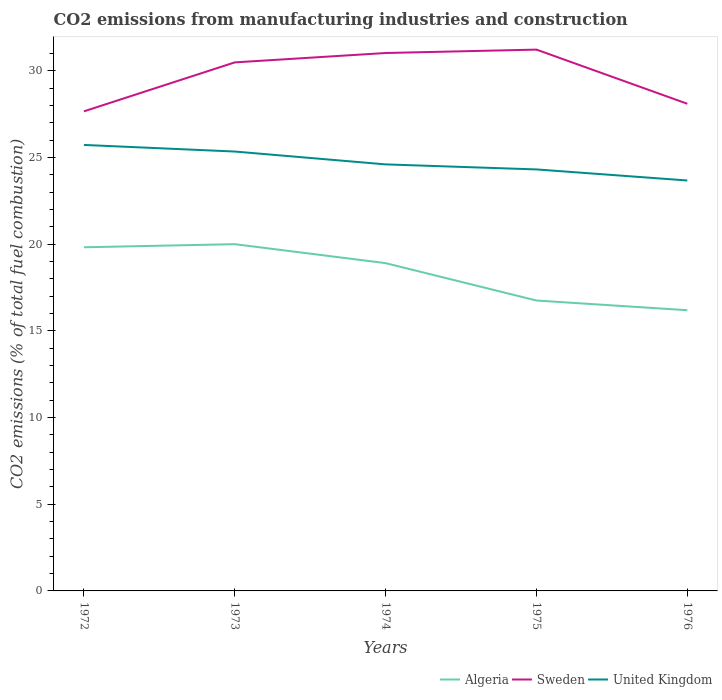Is the number of lines equal to the number of legend labels?
Offer a very short reply. Yes. Across all years, what is the maximum amount of CO2 emitted in Algeria?
Your answer should be compact. 16.19. In which year was the amount of CO2 emitted in Sweden maximum?
Your answer should be compact. 1972. What is the total amount of CO2 emitted in United Kingdom in the graph?
Ensure brevity in your answer.  0.64. What is the difference between the highest and the second highest amount of CO2 emitted in Algeria?
Your response must be concise. 3.81. Is the amount of CO2 emitted in Algeria strictly greater than the amount of CO2 emitted in United Kingdom over the years?
Provide a short and direct response. Yes. Are the values on the major ticks of Y-axis written in scientific E-notation?
Your response must be concise. No. Does the graph contain any zero values?
Offer a very short reply. No. Does the graph contain grids?
Your answer should be very brief. No. How many legend labels are there?
Provide a succinct answer. 3. What is the title of the graph?
Offer a terse response. CO2 emissions from manufacturing industries and construction. What is the label or title of the X-axis?
Offer a very short reply. Years. What is the label or title of the Y-axis?
Keep it short and to the point. CO2 emissions (% of total fuel combustion). What is the CO2 emissions (% of total fuel combustion) of Algeria in 1972?
Keep it short and to the point. 19.82. What is the CO2 emissions (% of total fuel combustion) in Sweden in 1972?
Your answer should be compact. 27.66. What is the CO2 emissions (% of total fuel combustion) of United Kingdom in 1972?
Give a very brief answer. 25.72. What is the CO2 emissions (% of total fuel combustion) of Sweden in 1973?
Make the answer very short. 30.48. What is the CO2 emissions (% of total fuel combustion) of United Kingdom in 1973?
Keep it short and to the point. 25.34. What is the CO2 emissions (% of total fuel combustion) in Algeria in 1974?
Provide a short and direct response. 18.91. What is the CO2 emissions (% of total fuel combustion) in Sweden in 1974?
Your response must be concise. 31.03. What is the CO2 emissions (% of total fuel combustion) of United Kingdom in 1974?
Offer a terse response. 24.6. What is the CO2 emissions (% of total fuel combustion) in Algeria in 1975?
Provide a short and direct response. 16.75. What is the CO2 emissions (% of total fuel combustion) of Sweden in 1975?
Your response must be concise. 31.22. What is the CO2 emissions (% of total fuel combustion) of United Kingdom in 1975?
Make the answer very short. 24.31. What is the CO2 emissions (% of total fuel combustion) of Algeria in 1976?
Your answer should be compact. 16.19. What is the CO2 emissions (% of total fuel combustion) of Sweden in 1976?
Keep it short and to the point. 28.1. What is the CO2 emissions (% of total fuel combustion) in United Kingdom in 1976?
Provide a succinct answer. 23.67. Across all years, what is the maximum CO2 emissions (% of total fuel combustion) of Sweden?
Your response must be concise. 31.22. Across all years, what is the maximum CO2 emissions (% of total fuel combustion) of United Kingdom?
Give a very brief answer. 25.72. Across all years, what is the minimum CO2 emissions (% of total fuel combustion) of Algeria?
Your answer should be very brief. 16.19. Across all years, what is the minimum CO2 emissions (% of total fuel combustion) of Sweden?
Your response must be concise. 27.66. Across all years, what is the minimum CO2 emissions (% of total fuel combustion) of United Kingdom?
Your response must be concise. 23.67. What is the total CO2 emissions (% of total fuel combustion) of Algeria in the graph?
Provide a succinct answer. 91.67. What is the total CO2 emissions (% of total fuel combustion) of Sweden in the graph?
Give a very brief answer. 148.49. What is the total CO2 emissions (% of total fuel combustion) of United Kingdom in the graph?
Provide a succinct answer. 123.65. What is the difference between the CO2 emissions (% of total fuel combustion) of Algeria in 1972 and that in 1973?
Offer a very short reply. -0.18. What is the difference between the CO2 emissions (% of total fuel combustion) in Sweden in 1972 and that in 1973?
Offer a very short reply. -2.82. What is the difference between the CO2 emissions (% of total fuel combustion) of United Kingdom in 1972 and that in 1973?
Provide a succinct answer. 0.38. What is the difference between the CO2 emissions (% of total fuel combustion) in Algeria in 1972 and that in 1974?
Your answer should be very brief. 0.91. What is the difference between the CO2 emissions (% of total fuel combustion) in Sweden in 1972 and that in 1974?
Keep it short and to the point. -3.37. What is the difference between the CO2 emissions (% of total fuel combustion) in United Kingdom in 1972 and that in 1974?
Ensure brevity in your answer.  1.12. What is the difference between the CO2 emissions (% of total fuel combustion) in Algeria in 1972 and that in 1975?
Your answer should be very brief. 3.07. What is the difference between the CO2 emissions (% of total fuel combustion) of Sweden in 1972 and that in 1975?
Offer a very short reply. -3.56. What is the difference between the CO2 emissions (% of total fuel combustion) of United Kingdom in 1972 and that in 1975?
Offer a terse response. 1.41. What is the difference between the CO2 emissions (% of total fuel combustion) of Algeria in 1972 and that in 1976?
Provide a short and direct response. 3.63. What is the difference between the CO2 emissions (% of total fuel combustion) in Sweden in 1972 and that in 1976?
Provide a succinct answer. -0.44. What is the difference between the CO2 emissions (% of total fuel combustion) in United Kingdom in 1972 and that in 1976?
Offer a very short reply. 2.05. What is the difference between the CO2 emissions (% of total fuel combustion) in Algeria in 1973 and that in 1974?
Your response must be concise. 1.09. What is the difference between the CO2 emissions (% of total fuel combustion) in Sweden in 1973 and that in 1974?
Your answer should be very brief. -0.54. What is the difference between the CO2 emissions (% of total fuel combustion) in United Kingdom in 1973 and that in 1974?
Provide a short and direct response. 0.74. What is the difference between the CO2 emissions (% of total fuel combustion) of Algeria in 1973 and that in 1975?
Your answer should be very brief. 3.25. What is the difference between the CO2 emissions (% of total fuel combustion) of Sweden in 1973 and that in 1975?
Provide a short and direct response. -0.74. What is the difference between the CO2 emissions (% of total fuel combustion) in United Kingdom in 1973 and that in 1975?
Offer a very short reply. 1.03. What is the difference between the CO2 emissions (% of total fuel combustion) in Algeria in 1973 and that in 1976?
Offer a very short reply. 3.81. What is the difference between the CO2 emissions (% of total fuel combustion) of Sweden in 1973 and that in 1976?
Your answer should be very brief. 2.39. What is the difference between the CO2 emissions (% of total fuel combustion) in United Kingdom in 1973 and that in 1976?
Offer a very short reply. 1.67. What is the difference between the CO2 emissions (% of total fuel combustion) of Algeria in 1974 and that in 1975?
Offer a terse response. 2.16. What is the difference between the CO2 emissions (% of total fuel combustion) in Sweden in 1974 and that in 1975?
Provide a short and direct response. -0.2. What is the difference between the CO2 emissions (% of total fuel combustion) in United Kingdom in 1974 and that in 1975?
Offer a very short reply. 0.29. What is the difference between the CO2 emissions (% of total fuel combustion) of Algeria in 1974 and that in 1976?
Offer a terse response. 2.72. What is the difference between the CO2 emissions (% of total fuel combustion) of Sweden in 1974 and that in 1976?
Your answer should be very brief. 2.93. What is the difference between the CO2 emissions (% of total fuel combustion) of United Kingdom in 1974 and that in 1976?
Offer a terse response. 0.93. What is the difference between the CO2 emissions (% of total fuel combustion) in Algeria in 1975 and that in 1976?
Make the answer very short. 0.56. What is the difference between the CO2 emissions (% of total fuel combustion) of Sweden in 1975 and that in 1976?
Provide a succinct answer. 3.12. What is the difference between the CO2 emissions (% of total fuel combustion) of United Kingdom in 1975 and that in 1976?
Your answer should be compact. 0.64. What is the difference between the CO2 emissions (% of total fuel combustion) of Algeria in 1972 and the CO2 emissions (% of total fuel combustion) of Sweden in 1973?
Your answer should be very brief. -10.66. What is the difference between the CO2 emissions (% of total fuel combustion) in Algeria in 1972 and the CO2 emissions (% of total fuel combustion) in United Kingdom in 1973?
Your answer should be compact. -5.52. What is the difference between the CO2 emissions (% of total fuel combustion) of Sweden in 1972 and the CO2 emissions (% of total fuel combustion) of United Kingdom in 1973?
Ensure brevity in your answer.  2.32. What is the difference between the CO2 emissions (% of total fuel combustion) of Algeria in 1972 and the CO2 emissions (% of total fuel combustion) of Sweden in 1974?
Your answer should be compact. -11.21. What is the difference between the CO2 emissions (% of total fuel combustion) of Algeria in 1972 and the CO2 emissions (% of total fuel combustion) of United Kingdom in 1974?
Provide a succinct answer. -4.78. What is the difference between the CO2 emissions (% of total fuel combustion) of Sweden in 1972 and the CO2 emissions (% of total fuel combustion) of United Kingdom in 1974?
Your response must be concise. 3.06. What is the difference between the CO2 emissions (% of total fuel combustion) in Algeria in 1972 and the CO2 emissions (% of total fuel combustion) in Sweden in 1975?
Offer a terse response. -11.4. What is the difference between the CO2 emissions (% of total fuel combustion) of Algeria in 1972 and the CO2 emissions (% of total fuel combustion) of United Kingdom in 1975?
Provide a short and direct response. -4.49. What is the difference between the CO2 emissions (% of total fuel combustion) of Sweden in 1972 and the CO2 emissions (% of total fuel combustion) of United Kingdom in 1975?
Offer a very short reply. 3.35. What is the difference between the CO2 emissions (% of total fuel combustion) of Algeria in 1972 and the CO2 emissions (% of total fuel combustion) of Sweden in 1976?
Give a very brief answer. -8.28. What is the difference between the CO2 emissions (% of total fuel combustion) in Algeria in 1972 and the CO2 emissions (% of total fuel combustion) in United Kingdom in 1976?
Your answer should be compact. -3.85. What is the difference between the CO2 emissions (% of total fuel combustion) of Sweden in 1972 and the CO2 emissions (% of total fuel combustion) of United Kingdom in 1976?
Provide a succinct answer. 3.99. What is the difference between the CO2 emissions (% of total fuel combustion) of Algeria in 1973 and the CO2 emissions (% of total fuel combustion) of Sweden in 1974?
Offer a very short reply. -11.03. What is the difference between the CO2 emissions (% of total fuel combustion) in Algeria in 1973 and the CO2 emissions (% of total fuel combustion) in United Kingdom in 1974?
Your answer should be compact. -4.6. What is the difference between the CO2 emissions (% of total fuel combustion) of Sweden in 1973 and the CO2 emissions (% of total fuel combustion) of United Kingdom in 1974?
Offer a terse response. 5.88. What is the difference between the CO2 emissions (% of total fuel combustion) in Algeria in 1973 and the CO2 emissions (% of total fuel combustion) in Sweden in 1975?
Provide a short and direct response. -11.22. What is the difference between the CO2 emissions (% of total fuel combustion) in Algeria in 1973 and the CO2 emissions (% of total fuel combustion) in United Kingdom in 1975?
Offer a very short reply. -4.31. What is the difference between the CO2 emissions (% of total fuel combustion) in Sweden in 1973 and the CO2 emissions (% of total fuel combustion) in United Kingdom in 1975?
Ensure brevity in your answer.  6.17. What is the difference between the CO2 emissions (% of total fuel combustion) in Algeria in 1973 and the CO2 emissions (% of total fuel combustion) in Sweden in 1976?
Offer a terse response. -8.1. What is the difference between the CO2 emissions (% of total fuel combustion) in Algeria in 1973 and the CO2 emissions (% of total fuel combustion) in United Kingdom in 1976?
Give a very brief answer. -3.67. What is the difference between the CO2 emissions (% of total fuel combustion) in Sweden in 1973 and the CO2 emissions (% of total fuel combustion) in United Kingdom in 1976?
Provide a succinct answer. 6.81. What is the difference between the CO2 emissions (% of total fuel combustion) of Algeria in 1974 and the CO2 emissions (% of total fuel combustion) of Sweden in 1975?
Your answer should be compact. -12.32. What is the difference between the CO2 emissions (% of total fuel combustion) in Algeria in 1974 and the CO2 emissions (% of total fuel combustion) in United Kingdom in 1975?
Make the answer very short. -5.41. What is the difference between the CO2 emissions (% of total fuel combustion) in Sweden in 1974 and the CO2 emissions (% of total fuel combustion) in United Kingdom in 1975?
Ensure brevity in your answer.  6.71. What is the difference between the CO2 emissions (% of total fuel combustion) of Algeria in 1974 and the CO2 emissions (% of total fuel combustion) of Sweden in 1976?
Make the answer very short. -9.19. What is the difference between the CO2 emissions (% of total fuel combustion) in Algeria in 1974 and the CO2 emissions (% of total fuel combustion) in United Kingdom in 1976?
Provide a succinct answer. -4.77. What is the difference between the CO2 emissions (% of total fuel combustion) of Sweden in 1974 and the CO2 emissions (% of total fuel combustion) of United Kingdom in 1976?
Your response must be concise. 7.35. What is the difference between the CO2 emissions (% of total fuel combustion) in Algeria in 1975 and the CO2 emissions (% of total fuel combustion) in Sweden in 1976?
Offer a very short reply. -11.35. What is the difference between the CO2 emissions (% of total fuel combustion) of Algeria in 1975 and the CO2 emissions (% of total fuel combustion) of United Kingdom in 1976?
Your answer should be very brief. -6.92. What is the difference between the CO2 emissions (% of total fuel combustion) in Sweden in 1975 and the CO2 emissions (% of total fuel combustion) in United Kingdom in 1976?
Provide a short and direct response. 7.55. What is the average CO2 emissions (% of total fuel combustion) in Algeria per year?
Make the answer very short. 18.33. What is the average CO2 emissions (% of total fuel combustion) of Sweden per year?
Make the answer very short. 29.7. What is the average CO2 emissions (% of total fuel combustion) of United Kingdom per year?
Your response must be concise. 24.73. In the year 1972, what is the difference between the CO2 emissions (% of total fuel combustion) in Algeria and CO2 emissions (% of total fuel combustion) in Sweden?
Ensure brevity in your answer.  -7.84. In the year 1972, what is the difference between the CO2 emissions (% of total fuel combustion) in Algeria and CO2 emissions (% of total fuel combustion) in United Kingdom?
Ensure brevity in your answer.  -5.9. In the year 1972, what is the difference between the CO2 emissions (% of total fuel combustion) in Sweden and CO2 emissions (% of total fuel combustion) in United Kingdom?
Offer a very short reply. 1.94. In the year 1973, what is the difference between the CO2 emissions (% of total fuel combustion) of Algeria and CO2 emissions (% of total fuel combustion) of Sweden?
Keep it short and to the point. -10.48. In the year 1973, what is the difference between the CO2 emissions (% of total fuel combustion) in Algeria and CO2 emissions (% of total fuel combustion) in United Kingdom?
Your response must be concise. -5.34. In the year 1973, what is the difference between the CO2 emissions (% of total fuel combustion) of Sweden and CO2 emissions (% of total fuel combustion) of United Kingdom?
Your answer should be compact. 5.14. In the year 1974, what is the difference between the CO2 emissions (% of total fuel combustion) of Algeria and CO2 emissions (% of total fuel combustion) of Sweden?
Offer a very short reply. -12.12. In the year 1974, what is the difference between the CO2 emissions (% of total fuel combustion) of Algeria and CO2 emissions (% of total fuel combustion) of United Kingdom?
Provide a succinct answer. -5.7. In the year 1974, what is the difference between the CO2 emissions (% of total fuel combustion) of Sweden and CO2 emissions (% of total fuel combustion) of United Kingdom?
Provide a short and direct response. 6.42. In the year 1975, what is the difference between the CO2 emissions (% of total fuel combustion) of Algeria and CO2 emissions (% of total fuel combustion) of Sweden?
Offer a very short reply. -14.47. In the year 1975, what is the difference between the CO2 emissions (% of total fuel combustion) in Algeria and CO2 emissions (% of total fuel combustion) in United Kingdom?
Offer a terse response. -7.56. In the year 1975, what is the difference between the CO2 emissions (% of total fuel combustion) of Sweden and CO2 emissions (% of total fuel combustion) of United Kingdom?
Keep it short and to the point. 6.91. In the year 1976, what is the difference between the CO2 emissions (% of total fuel combustion) in Algeria and CO2 emissions (% of total fuel combustion) in Sweden?
Make the answer very short. -11.91. In the year 1976, what is the difference between the CO2 emissions (% of total fuel combustion) of Algeria and CO2 emissions (% of total fuel combustion) of United Kingdom?
Offer a very short reply. -7.48. In the year 1976, what is the difference between the CO2 emissions (% of total fuel combustion) of Sweden and CO2 emissions (% of total fuel combustion) of United Kingdom?
Make the answer very short. 4.43. What is the ratio of the CO2 emissions (% of total fuel combustion) of Algeria in 1972 to that in 1973?
Give a very brief answer. 0.99. What is the ratio of the CO2 emissions (% of total fuel combustion) of Sweden in 1972 to that in 1973?
Ensure brevity in your answer.  0.91. What is the ratio of the CO2 emissions (% of total fuel combustion) in United Kingdom in 1972 to that in 1973?
Provide a succinct answer. 1.01. What is the ratio of the CO2 emissions (% of total fuel combustion) in Algeria in 1972 to that in 1974?
Your answer should be very brief. 1.05. What is the ratio of the CO2 emissions (% of total fuel combustion) of Sweden in 1972 to that in 1974?
Offer a very short reply. 0.89. What is the ratio of the CO2 emissions (% of total fuel combustion) of United Kingdom in 1972 to that in 1974?
Make the answer very short. 1.05. What is the ratio of the CO2 emissions (% of total fuel combustion) in Algeria in 1972 to that in 1975?
Make the answer very short. 1.18. What is the ratio of the CO2 emissions (% of total fuel combustion) of Sweden in 1972 to that in 1975?
Give a very brief answer. 0.89. What is the ratio of the CO2 emissions (% of total fuel combustion) of United Kingdom in 1972 to that in 1975?
Provide a succinct answer. 1.06. What is the ratio of the CO2 emissions (% of total fuel combustion) of Algeria in 1972 to that in 1976?
Make the answer very short. 1.22. What is the ratio of the CO2 emissions (% of total fuel combustion) of Sweden in 1972 to that in 1976?
Provide a short and direct response. 0.98. What is the ratio of the CO2 emissions (% of total fuel combustion) of United Kingdom in 1972 to that in 1976?
Your answer should be very brief. 1.09. What is the ratio of the CO2 emissions (% of total fuel combustion) in Algeria in 1973 to that in 1974?
Give a very brief answer. 1.06. What is the ratio of the CO2 emissions (% of total fuel combustion) of Sweden in 1973 to that in 1974?
Ensure brevity in your answer.  0.98. What is the ratio of the CO2 emissions (% of total fuel combustion) in United Kingdom in 1973 to that in 1974?
Offer a very short reply. 1.03. What is the ratio of the CO2 emissions (% of total fuel combustion) of Algeria in 1973 to that in 1975?
Your answer should be very brief. 1.19. What is the ratio of the CO2 emissions (% of total fuel combustion) in Sweden in 1973 to that in 1975?
Ensure brevity in your answer.  0.98. What is the ratio of the CO2 emissions (% of total fuel combustion) in United Kingdom in 1973 to that in 1975?
Provide a succinct answer. 1.04. What is the ratio of the CO2 emissions (% of total fuel combustion) of Algeria in 1973 to that in 1976?
Ensure brevity in your answer.  1.24. What is the ratio of the CO2 emissions (% of total fuel combustion) of Sweden in 1973 to that in 1976?
Offer a terse response. 1.08. What is the ratio of the CO2 emissions (% of total fuel combustion) in United Kingdom in 1973 to that in 1976?
Ensure brevity in your answer.  1.07. What is the ratio of the CO2 emissions (% of total fuel combustion) in Algeria in 1974 to that in 1975?
Offer a very short reply. 1.13. What is the ratio of the CO2 emissions (% of total fuel combustion) of Sweden in 1974 to that in 1975?
Ensure brevity in your answer.  0.99. What is the ratio of the CO2 emissions (% of total fuel combustion) of Algeria in 1974 to that in 1976?
Your answer should be very brief. 1.17. What is the ratio of the CO2 emissions (% of total fuel combustion) of Sweden in 1974 to that in 1976?
Your answer should be compact. 1.1. What is the ratio of the CO2 emissions (% of total fuel combustion) of United Kingdom in 1974 to that in 1976?
Offer a very short reply. 1.04. What is the ratio of the CO2 emissions (% of total fuel combustion) in Algeria in 1975 to that in 1976?
Your answer should be very brief. 1.03. What is the ratio of the CO2 emissions (% of total fuel combustion) in Sweden in 1975 to that in 1976?
Your response must be concise. 1.11. What is the ratio of the CO2 emissions (% of total fuel combustion) in United Kingdom in 1975 to that in 1976?
Provide a succinct answer. 1.03. What is the difference between the highest and the second highest CO2 emissions (% of total fuel combustion) of Algeria?
Keep it short and to the point. 0.18. What is the difference between the highest and the second highest CO2 emissions (% of total fuel combustion) in Sweden?
Provide a short and direct response. 0.2. What is the difference between the highest and the second highest CO2 emissions (% of total fuel combustion) in United Kingdom?
Your response must be concise. 0.38. What is the difference between the highest and the lowest CO2 emissions (% of total fuel combustion) of Algeria?
Give a very brief answer. 3.81. What is the difference between the highest and the lowest CO2 emissions (% of total fuel combustion) of Sweden?
Offer a very short reply. 3.56. What is the difference between the highest and the lowest CO2 emissions (% of total fuel combustion) of United Kingdom?
Provide a short and direct response. 2.05. 